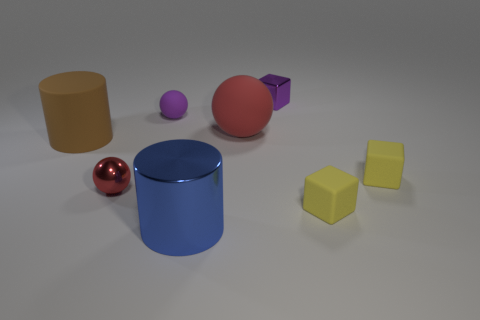What material is the other ball that is the same size as the purple sphere?
Offer a very short reply. Metal. What number of other things are made of the same material as the blue cylinder?
Ensure brevity in your answer.  2. What is the color of the matte object that is both right of the tiny red thing and on the left side of the large blue object?
Your answer should be very brief. Purple. How many things are small objects behind the big brown thing or purple rubber objects?
Offer a very short reply. 2. How many other objects are the same color as the shiny cylinder?
Your response must be concise. 0. Are there the same number of tiny matte cubes that are to the left of the small metallic sphere and yellow blocks?
Give a very brief answer. No. How many small rubber balls are left of the blue metallic cylinder that is on the right side of the large thing that is left of the big metal thing?
Provide a succinct answer. 1. There is a purple metallic cube; is it the same size as the metallic thing in front of the red metal ball?
Make the answer very short. No. How many tiny yellow blocks are there?
Your response must be concise. 2. There is a matte object behind the big red rubber sphere; is its size the same as the matte object to the left of the small red metallic object?
Provide a short and direct response. No. 